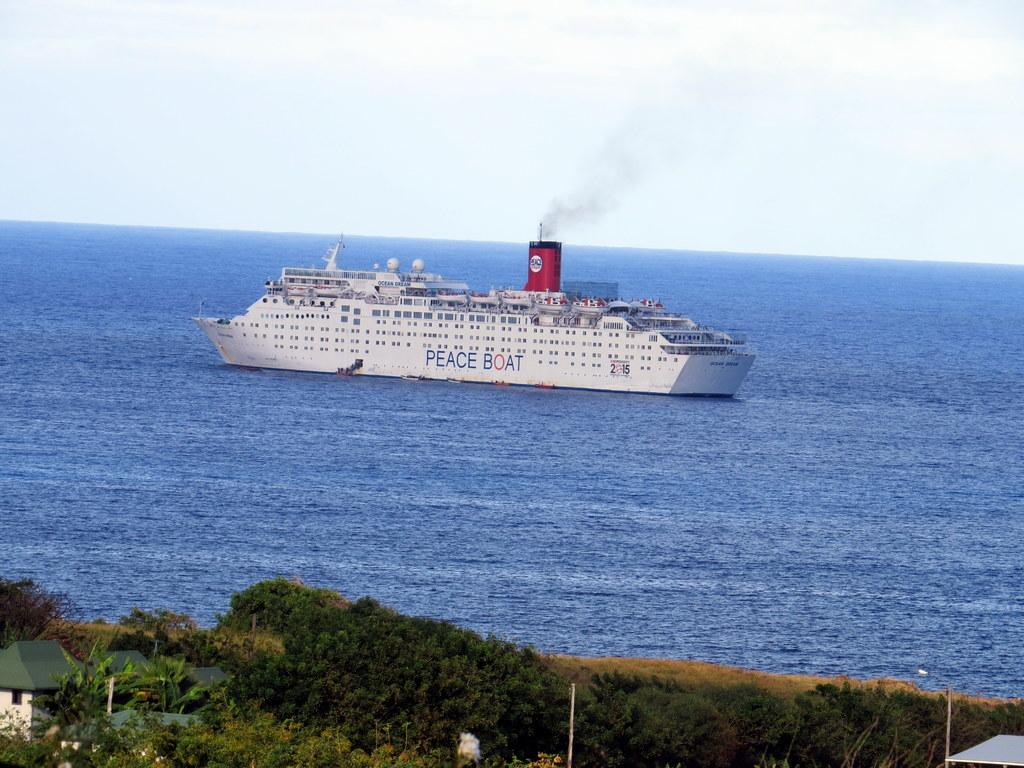What is the main subject in the water in the image? There is a ship in the water in the image. What can be seen in the foreground of the image? There is a building and a group of trees in the foreground. What other objects are visible in the foreground? Poles are visible in the foreground. What part of the natural environment is visible in the image? The sky is visible in the image. What type of songs can be heard coming from the ship in the image? There is no indication in the image that songs are being played or heard from the ship. 